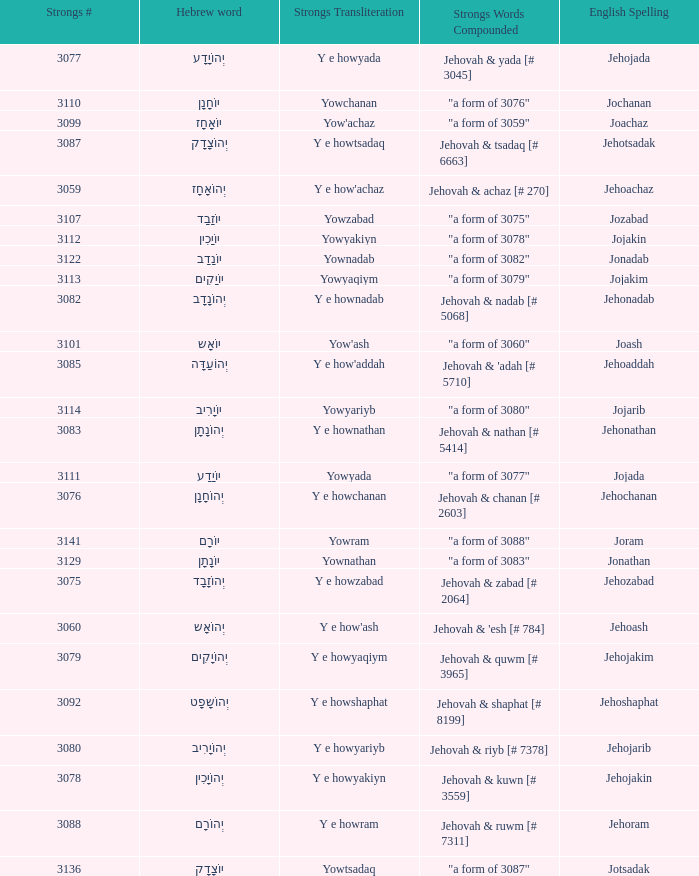What is the strongs words compounded when the english spelling is jonadab? "a form of 3082". 